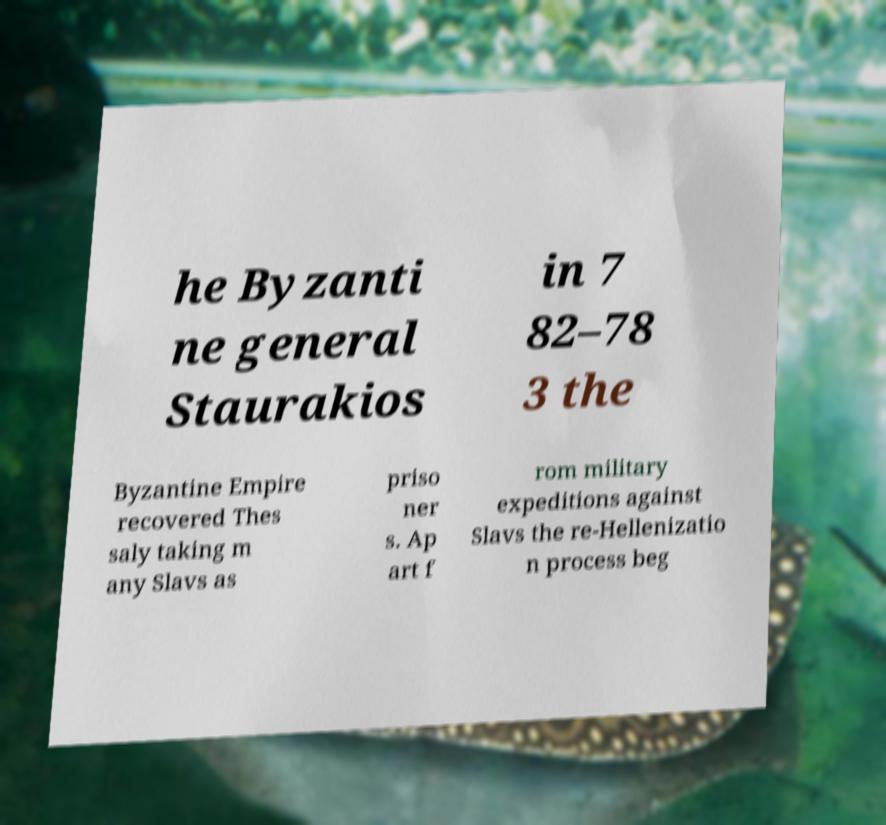Could you extract and type out the text from this image? he Byzanti ne general Staurakios in 7 82–78 3 the Byzantine Empire recovered Thes saly taking m any Slavs as priso ner s. Ap art f rom military expeditions against Slavs the re-Hellenizatio n process beg 